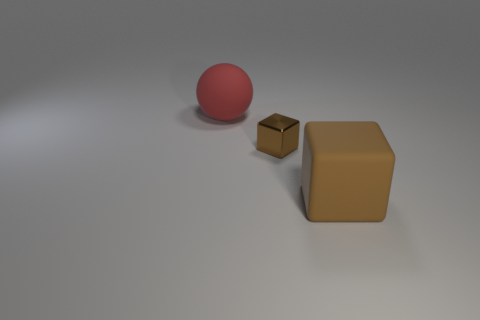Are there any big gray objects of the same shape as the small brown shiny thing?
Your answer should be very brief. No. What is the shape of the rubber object that is left of the brown thing that is behind the big brown cube?
Provide a short and direct response. Sphere. There is a large object in front of the big red matte sphere; what color is it?
Give a very brief answer. Brown. There is a cube that is the same material as the red ball; what size is it?
Your answer should be very brief. Large. What is the size of the other thing that is the same shape as the large brown object?
Offer a terse response. Small. Is there a big metallic object?
Make the answer very short. No. How many things are things on the left side of the brown matte object or big brown shiny spheres?
Offer a terse response. 2. There is a object that is the same size as the rubber sphere; what is its material?
Keep it short and to the point. Rubber. There is a large rubber object that is behind the rubber thing to the right of the shiny object; what color is it?
Keep it short and to the point. Red. There is a large brown cube; what number of brown things are behind it?
Offer a terse response. 1. 